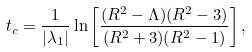<formula> <loc_0><loc_0><loc_500><loc_500>t _ { c } = \frac { 1 } { | \lambda _ { 1 } | } \ln \left [ \frac { ( R ^ { 2 } - \Lambda ) ( R ^ { 2 } - 3 ) } { ( R ^ { 2 } + 3 ) ( R ^ { 2 } - 1 ) } \right ] ,</formula> 